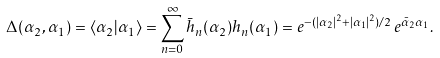<formula> <loc_0><loc_0><loc_500><loc_500>\Delta ( \alpha _ { 2 } , \alpha _ { 1 } ) = \langle \alpha _ { 2 } | \alpha _ { 1 } \rangle = \sum _ { n = 0 } ^ { \infty } \bar { h } _ { n } ( \alpha _ { 2 } ) h _ { n } ( \alpha _ { 1 } ) = e ^ { - ( | \alpha _ { 2 } | ^ { 2 } + | \alpha _ { 1 } | ^ { 2 } ) / 2 } \, e ^ { \bar { \alpha } _ { 2 } \alpha _ { 1 } } .</formula> 